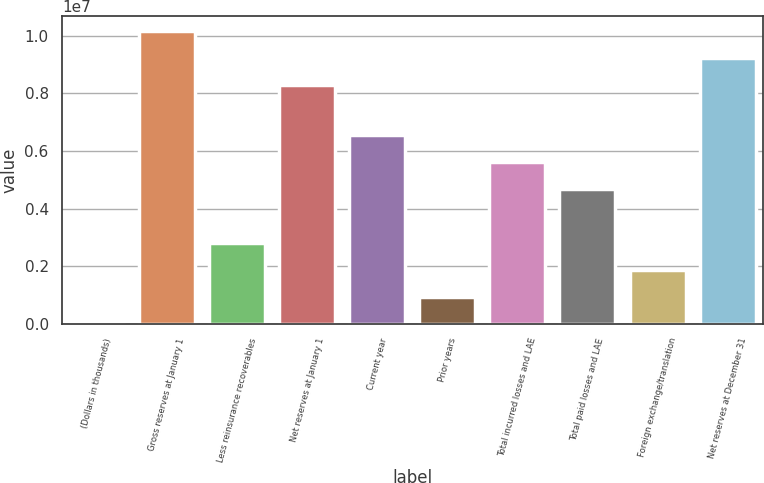Convert chart. <chart><loc_0><loc_0><loc_500><loc_500><bar_chart><fcel>(Dollars in thousands)<fcel>Gross reserves at January 1<fcel>Less reinsurance recoverables<fcel>Net reserves at January 1<fcel>Current year<fcel>Prior years<fcel>Total incurred losses and LAE<fcel>Total paid losses and LAE<fcel>Foreign exchange/translation<fcel>Net reserves at December 31<nl><fcel>2010<fcel>1.01642e+07<fcel>2.80346e+06<fcel>8.29659e+06<fcel>6.53873e+06<fcel>935827<fcel>5.60491e+06<fcel>4.6711e+06<fcel>1.86964e+06<fcel>9.23041e+06<nl></chart> 